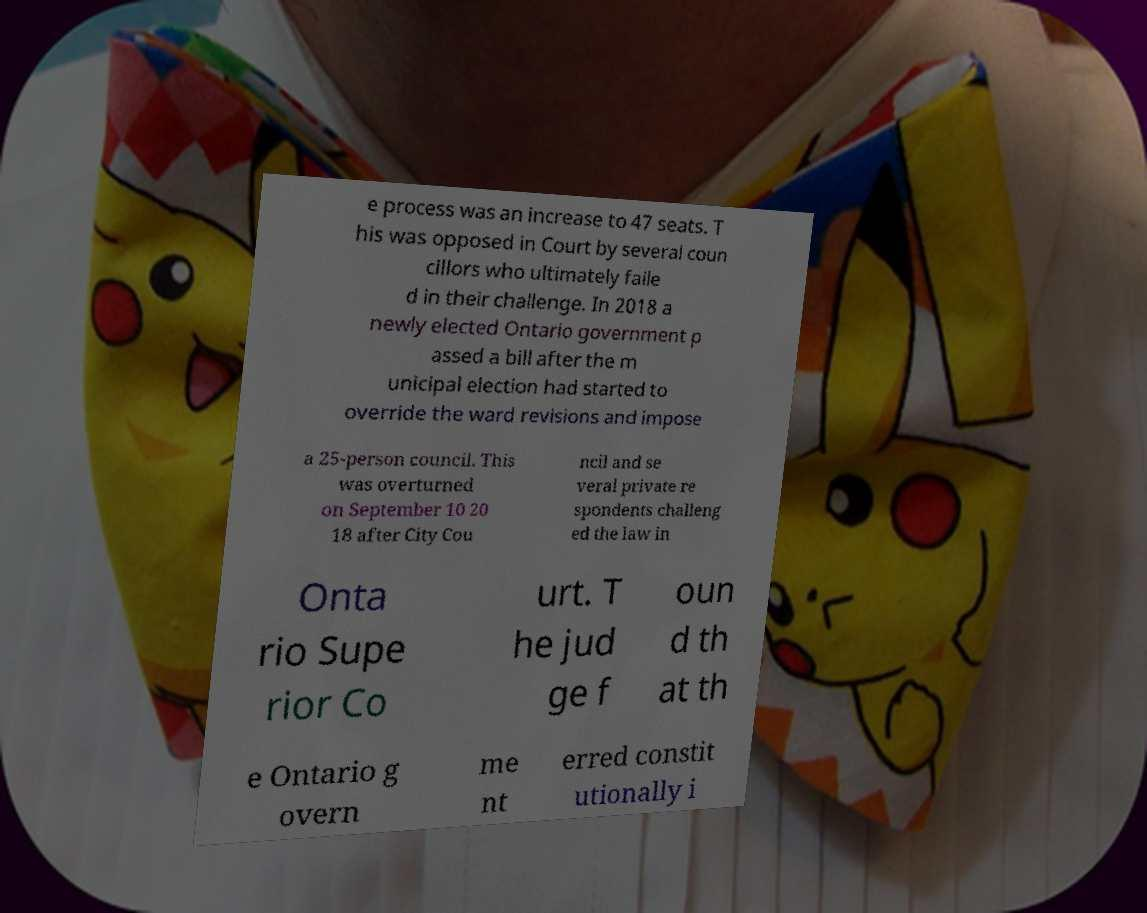Can you read and provide the text displayed in the image?This photo seems to have some interesting text. Can you extract and type it out for me? e process was an increase to 47 seats. T his was opposed in Court by several coun cillors who ultimately faile d in their challenge. In 2018 a newly elected Ontario government p assed a bill after the m unicipal election had started to override the ward revisions and impose a 25-person council. This was overturned on September 10 20 18 after City Cou ncil and se veral private re spondents challeng ed the law in Onta rio Supe rior Co urt. T he jud ge f oun d th at th e Ontario g overn me nt erred constit utionally i 